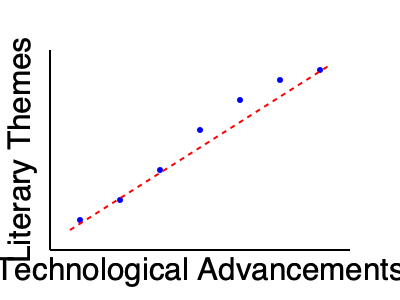Based on the scatter plot showing the correlation between technological advancements and literary themes in science fiction, what can be inferred about the relationship between these two variables, and how might this trend influence future sci-fi narratives? To interpret this scatter plot and its implications for future sci-fi narratives, let's break it down step-by-step:

1. Correlation observation: The scatter plot shows a clear negative correlation between technological advancements and the prevalence of certain literary themes in science fiction.

2. Trend analysis: As we move from left to right (increasing technological advancements), the data points trend downward, indicating a decrease in the occurrence or complexity of traditional literary themes.

3. Strength of relationship: The data points follow a fairly consistent pattern with minimal scatter, suggesting a strong relationship between the variables.

4. Extrapolation: If this trend continues, we can expect that as technology continues to advance, certain literary themes may become less prominent in science fiction.

5. Possible interpretations:
   a) As technology progresses, authors may focus more on the implications of specific technologies rather than broader, traditional themes.
   b) Advanced technology might become so integrated into the narrative that it's no longer a central theme but a backdrop for other storytelling elements.
   c) Writers may find it challenging to imagine futures that are significantly different from our increasingly high-tech present, leading to a shift in thematic focus.

6. Impact on future narratives:
   a) Sci-fi writers may need to explore more nuanced or specialized themes to keep their stories engaging and relevant.
   b) There could be a rise in "near-future" sci-fi that focuses on the immediate consequences of current technological trends.
   c) Authors might increasingly blend genres, incorporating elements of literary fiction, philosophy, or social commentary to add depth to their technologically advanced settings.

7. Potential for innovation: This trend could encourage writers to find creative ways to reintroduce or reimagine traditional themes within the context of highly advanced technological settings, potentially leading to new subgenres or narrative styles in science fiction.
Answer: Negative correlation between technological advancement and traditional sci-fi themes, suggesting future narratives may focus on more nuanced, technology-specific, or genre-blending storytelling approaches. 